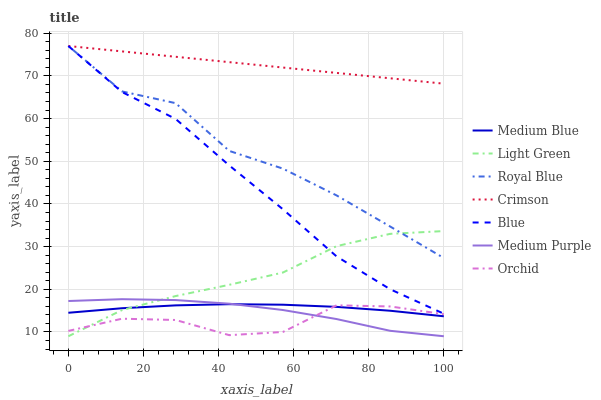Does Medium Blue have the minimum area under the curve?
Answer yes or no. No. Does Medium Blue have the maximum area under the curve?
Answer yes or no. No. Is Medium Blue the smoothest?
Answer yes or no. No. Is Medium Blue the roughest?
Answer yes or no. No. Does Medium Blue have the lowest value?
Answer yes or no. No. Does Medium Blue have the highest value?
Answer yes or no. No. Is Medium Blue less than Crimson?
Answer yes or no. Yes. Is Royal Blue greater than Medium Purple?
Answer yes or no. Yes. Does Medium Blue intersect Crimson?
Answer yes or no. No. 